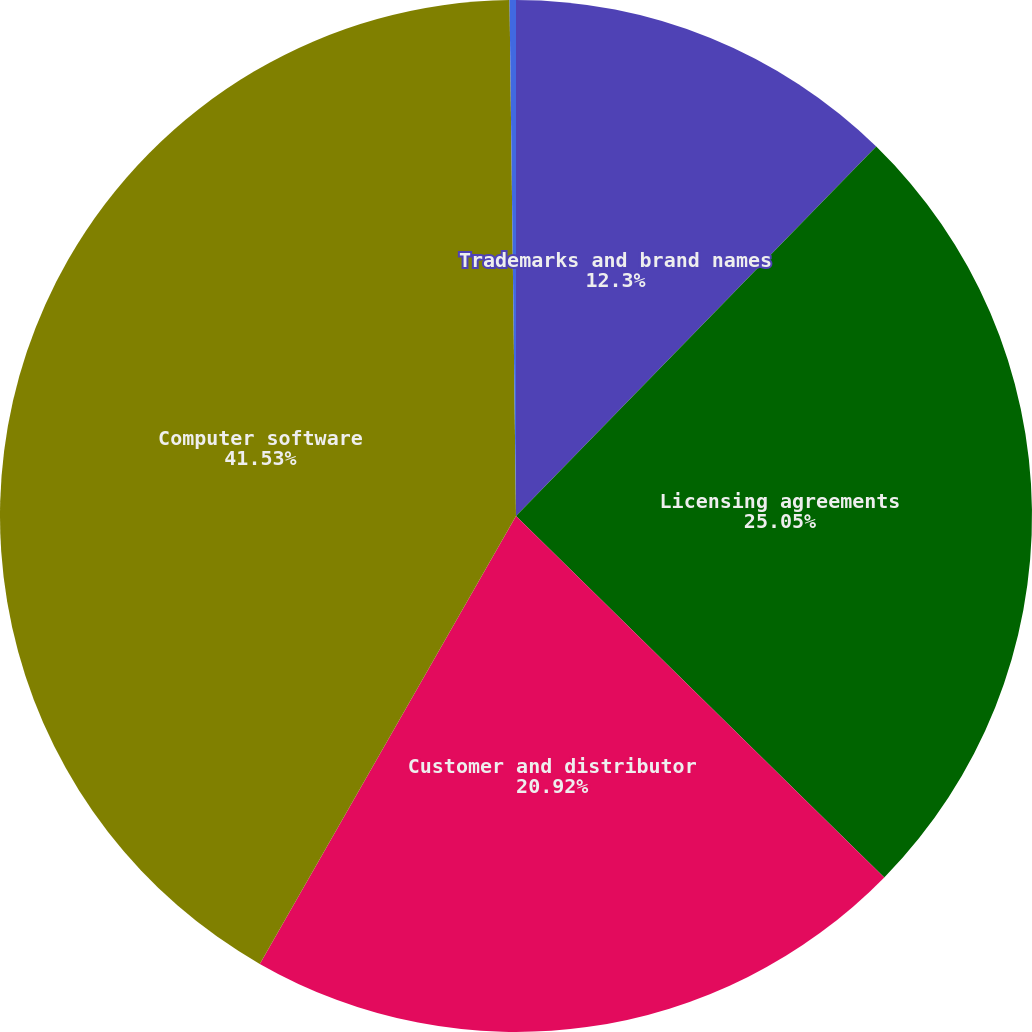Convert chart. <chart><loc_0><loc_0><loc_500><loc_500><pie_chart><fcel>Trademarks and brand names<fcel>Licensing agreements<fcel>Customer and distributor<fcel>Computer software<fcel>Other intangibles<nl><fcel>12.3%<fcel>25.05%<fcel>20.92%<fcel>41.53%<fcel>0.2%<nl></chart> 